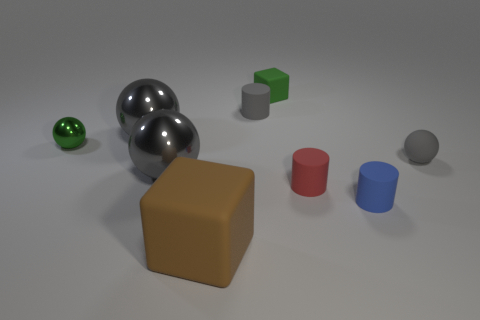How many other objects are there of the same color as the rubber sphere?
Make the answer very short. 3. What is the size of the rubber ball?
Your answer should be very brief. Small. How many big gray balls are behind the gray rubber object that is on the right side of the tiny blue rubber object?
Your answer should be compact. 1. What is the shape of the matte object that is left of the tiny block and to the right of the brown thing?
Your response must be concise. Cylinder. What number of metal balls have the same color as the rubber ball?
Your answer should be compact. 2. Are there any small matte blocks in front of the metal thing that is in front of the tiny gray object to the right of the red thing?
Keep it short and to the point. No. What size is the matte object that is right of the red rubber cylinder and to the left of the small gray matte sphere?
Offer a very short reply. Small. What number of red objects are the same material as the green sphere?
Ensure brevity in your answer.  0. How many cylinders are large brown matte objects or tiny yellow things?
Keep it short and to the point. 0. What is the size of the green object that is on the right side of the big ball that is behind the sphere right of the red rubber cylinder?
Provide a succinct answer. Small. 